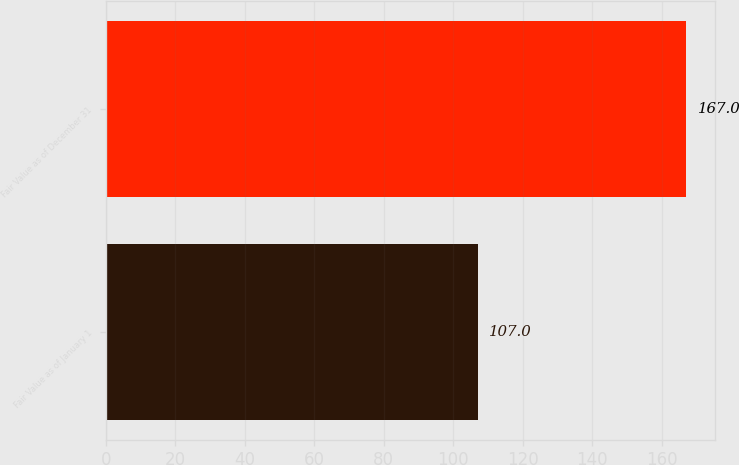Convert chart to OTSL. <chart><loc_0><loc_0><loc_500><loc_500><bar_chart><fcel>Fair Value as of January 1<fcel>Fair Value as of December 31<nl><fcel>107<fcel>167<nl></chart> 